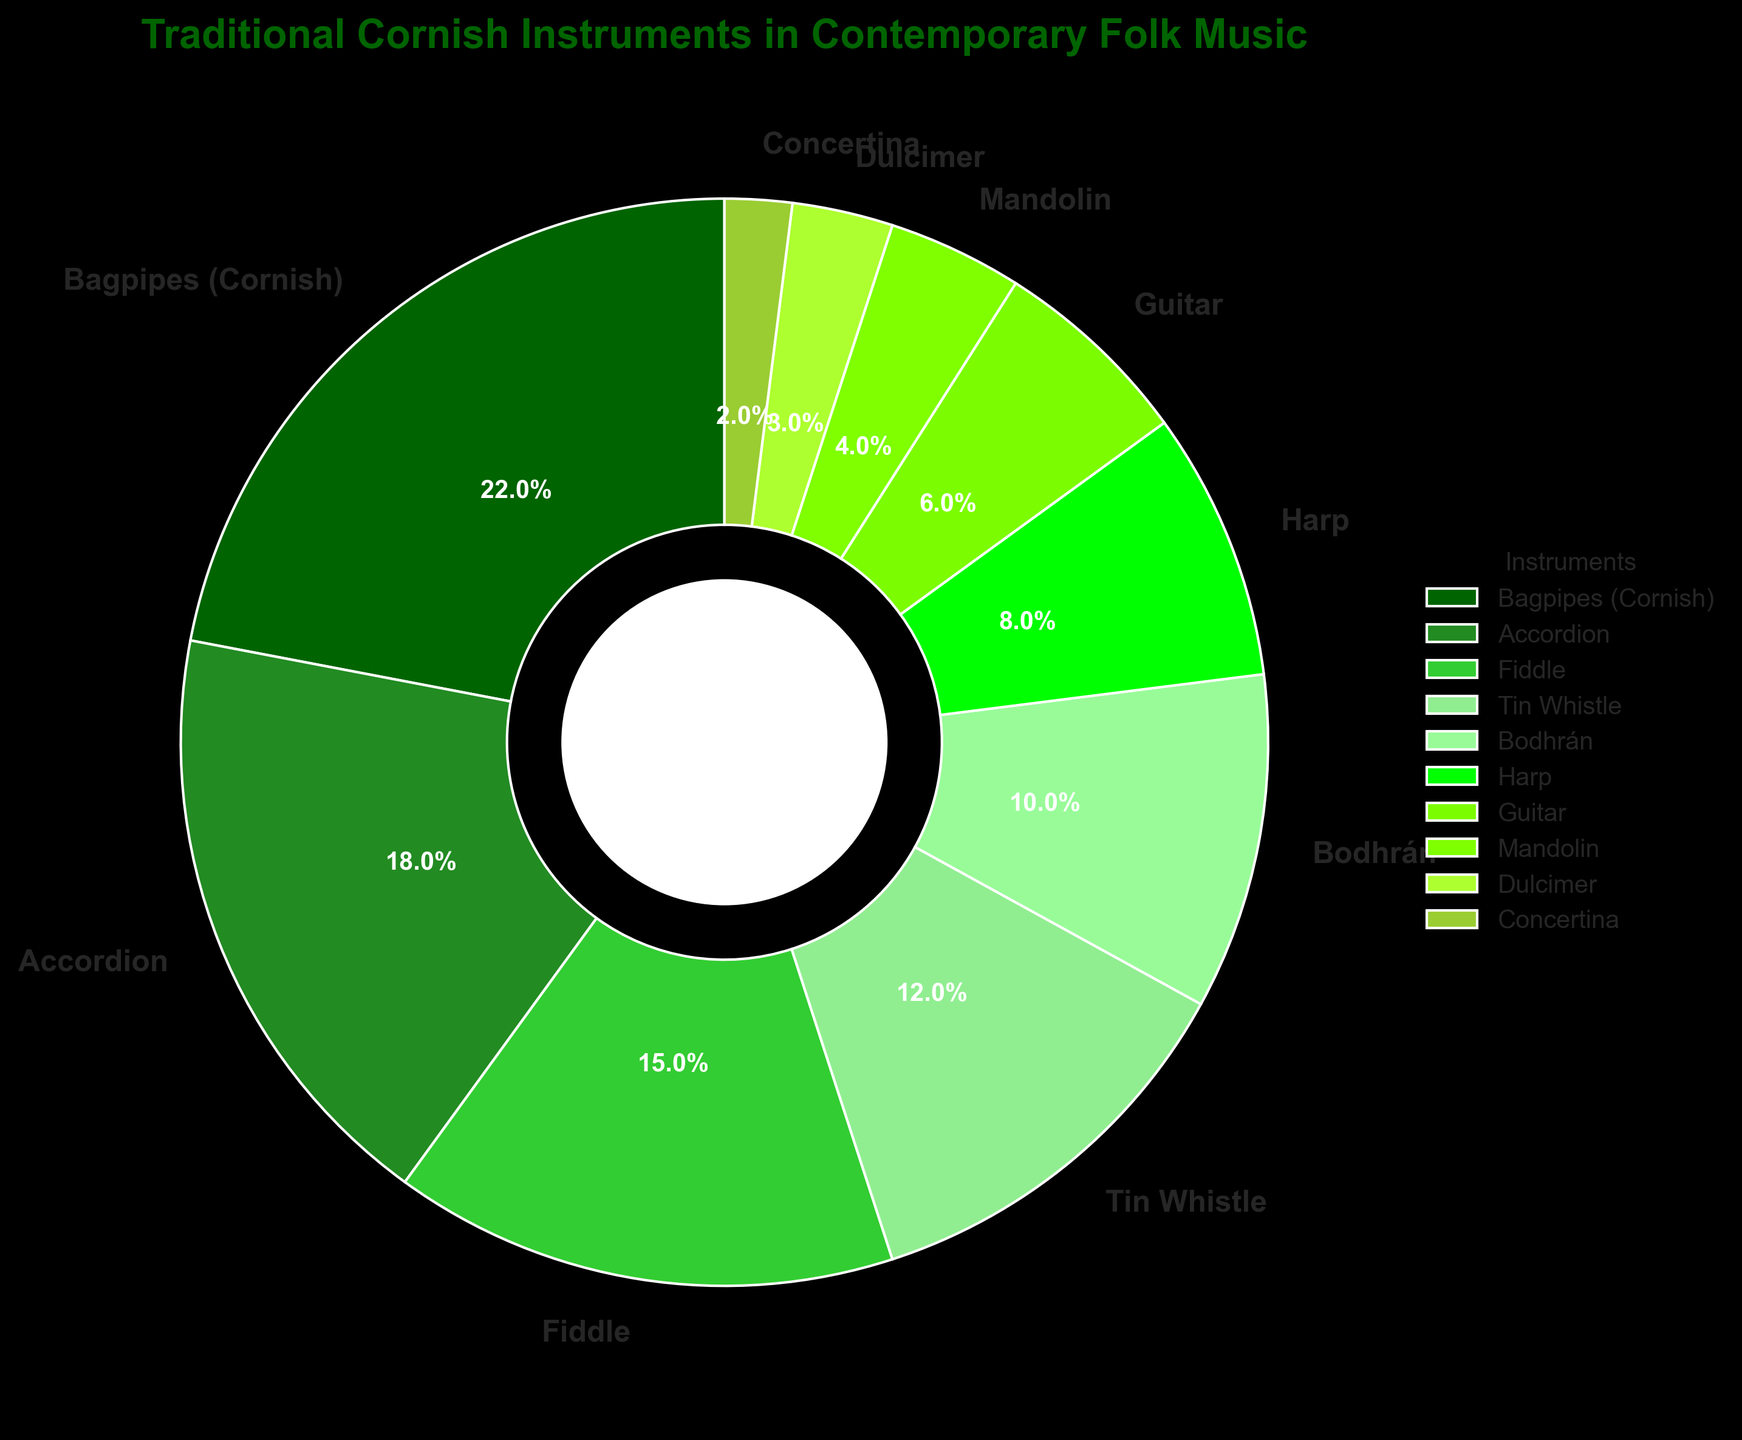Which instrument has the highest percentage in contemporary Cornish folk music? The instrument with the highest percentage is identified by the segment that occupies the largest portion of the pie chart. This is labeled directly on the chart.
Answer: Bagpipes (Cornish) Which two instruments together make up 50% of the total? To determine the instruments that together make up 50%, add the percentages of the largest segments until the sum is around 50%. The largest segment is Bagpipes (Cornish) with 22%, and the next largest is the Accordion with 18%. Together that is 22% + 18% = 40%. Adding the next largest, Fiddle (15%), sums to 55%, which is above 50%. Hence, Bagpipes (Cornish) and Accordion total to 40%, and adding Fiddle goes beyond 50%. Therefore, no exact 50% can be achieved with two instruments but these three exceed it.
Answer: Bagpipes (Cornish), Accordion, and Fiddle What is the difference in percentage between the Bodhrán and Tin Whistle? Locate the labeled segments for Bodhrán (10%) and Tin Whistle (12%) on the pie chart and subtract the smaller percentage from the larger one: 12% - 10%
Answer: 2% Are there more instruments with percentages below or above 10%? Count the number of instruments associated with percentages below 10% and those above 10%. Below 10%: Harp (8%), Guitar (6%), Mandolin (4%), Dulcimer (3%), Concertina (2%) - 5 instruments. Above 10%: Bagpipes (Cornish) (22%), Accordion (18%), Fiddle (15%), Tin Whistle (12%), Bodhrán (10%) - 5 instruments. Both categories have an equal count.
Answer: Equal What percentage of the total do the three least-used instruments constitute? Identify the three segments with the smallest percentages: Concertina (2%), Dulcimer (3%), and Mandolin (4%). Add these percentages: 2% + 3% + 4%
Answer: 9% Which instrument has the third highest percentage? The instrument with the third highest percentage can be found by ordering the segments by size. Bagpipes (Cornish) has the highest (22%), Accordion is second (18%), and the Fiddle is third (15%).
Answer: Fiddle What is the sum of the percentages for Guitar and Harp? To find the sum of these two instruments' percentages, locate and add their values on the pie chart. Guitar (6%) + Harp (8%)
Answer: 14% Which instruments have a percentage greater than that of both the Guitar and Harp? Identify segments that have percentages higher than both the Guitar (6%) and Harp (8%). These are Bagpipes (Cornish) (22%), Accordion (18%), Fiddle (15%), and Tin Whistle (12%).
Answer: Bagpipes (Cornish), Accordion, Fiddle, Tin Whistle 